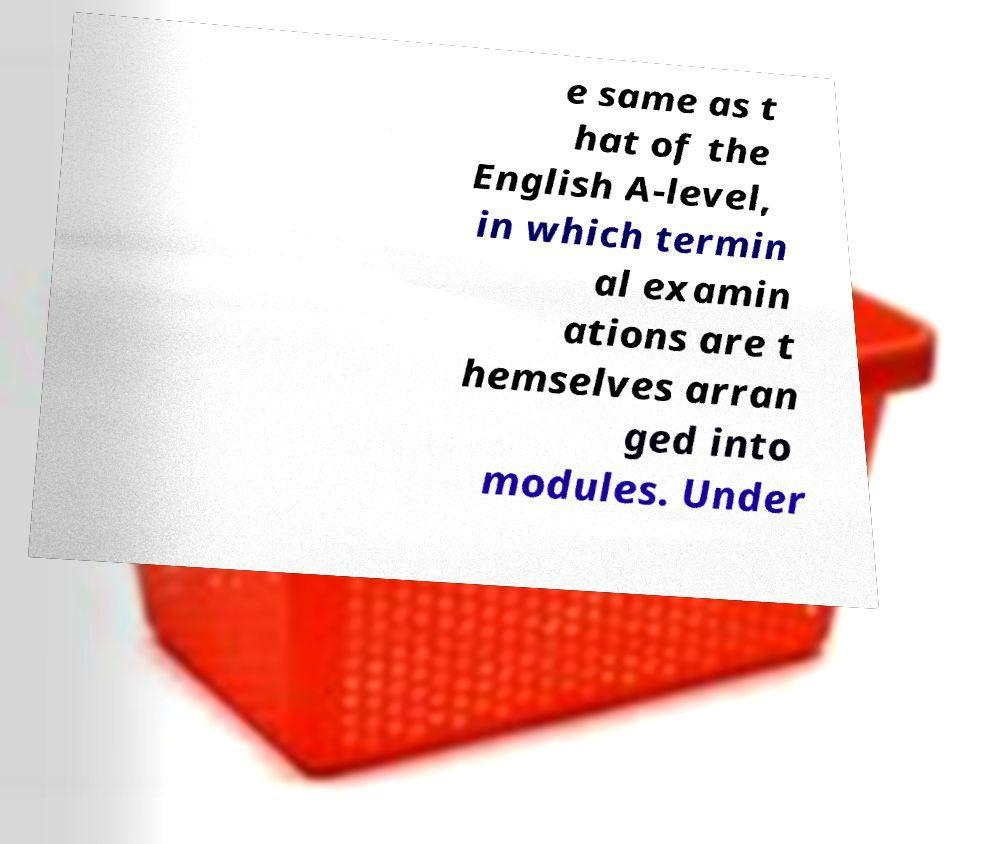Can you read and provide the text displayed in the image?This photo seems to have some interesting text. Can you extract and type it out for me? e same as t hat of the English A-level, in which termin al examin ations are t hemselves arran ged into modules. Under 